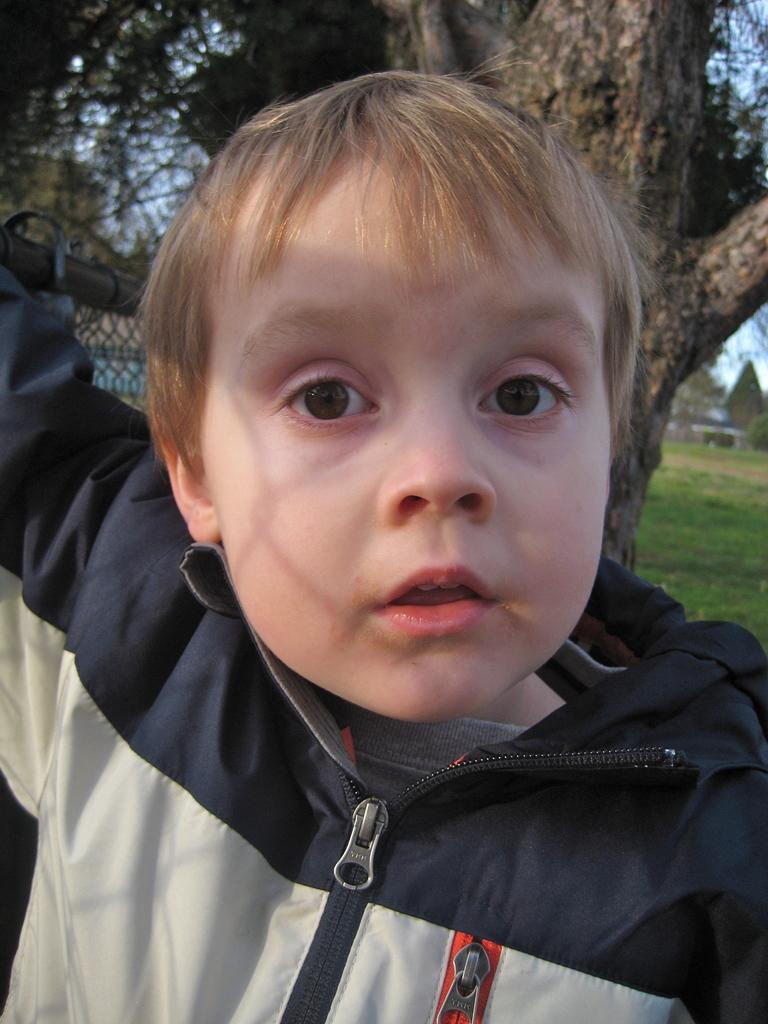What is the main subject of the image? There is a kid in the center of the image. What can be seen in the background of the image? There are trees, a building, and the sky visible in the background of the image. What type of industry can be seen in the image? There is no industry present in the image; it features a kid in the center and natural elements in the background. What channel is the kid watching in the image? There is no television or channel visible in the image. 